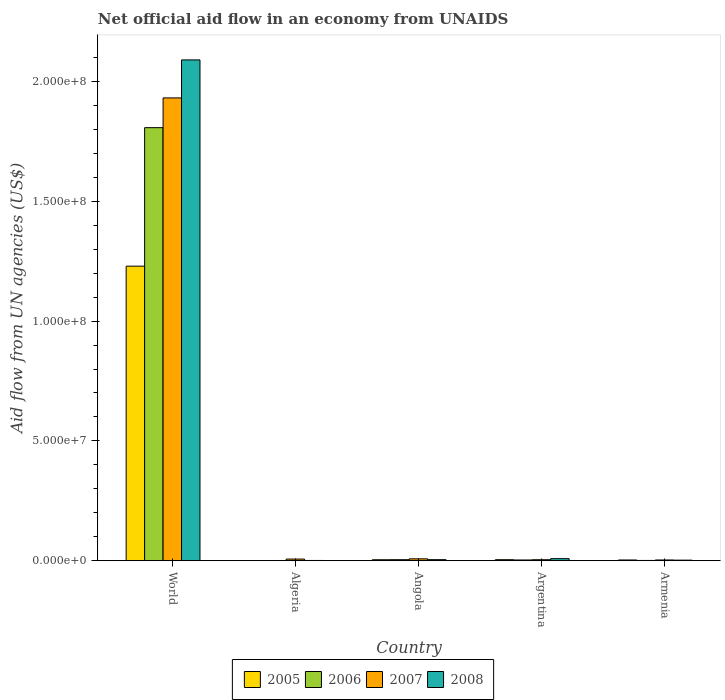Are the number of bars on each tick of the X-axis equal?
Provide a short and direct response. Yes. How many bars are there on the 3rd tick from the left?
Give a very brief answer. 4. How many bars are there on the 4th tick from the right?
Provide a succinct answer. 4. What is the label of the 4th group of bars from the left?
Give a very brief answer. Argentina. What is the net official aid flow in 2007 in World?
Provide a short and direct response. 1.93e+08. Across all countries, what is the maximum net official aid flow in 2005?
Your answer should be very brief. 1.23e+08. Across all countries, what is the minimum net official aid flow in 2007?
Offer a very short reply. 3.30e+05. In which country was the net official aid flow in 2007 minimum?
Offer a terse response. Armenia. What is the total net official aid flow in 2008 in the graph?
Your response must be concise. 2.11e+08. What is the difference between the net official aid flow in 2007 in Algeria and that in Angola?
Your response must be concise. -1.00e+05. What is the difference between the net official aid flow in 2006 in World and the net official aid flow in 2008 in Algeria?
Your response must be concise. 1.81e+08. What is the average net official aid flow in 2005 per country?
Make the answer very short. 2.48e+07. In how many countries, is the net official aid flow in 2007 greater than 50000000 US$?
Your answer should be very brief. 1. What is the ratio of the net official aid flow in 2005 in Algeria to that in Armenia?
Your response must be concise. 0.27. What is the difference between the highest and the second highest net official aid flow in 2006?
Your answer should be compact. 1.80e+08. What is the difference between the highest and the lowest net official aid flow in 2006?
Your answer should be very brief. 1.81e+08. Is it the case that in every country, the sum of the net official aid flow in 2008 and net official aid flow in 2006 is greater than the sum of net official aid flow in 2007 and net official aid flow in 2005?
Offer a very short reply. No. What does the 1st bar from the left in Armenia represents?
Offer a very short reply. 2005. How many bars are there?
Your answer should be very brief. 20. What is the difference between two consecutive major ticks on the Y-axis?
Provide a succinct answer. 5.00e+07. Are the values on the major ticks of Y-axis written in scientific E-notation?
Provide a succinct answer. Yes. Does the graph contain grids?
Your answer should be compact. No. Where does the legend appear in the graph?
Your answer should be very brief. Bottom center. How are the legend labels stacked?
Provide a short and direct response. Horizontal. What is the title of the graph?
Provide a short and direct response. Net official aid flow in an economy from UNAIDS. What is the label or title of the Y-axis?
Ensure brevity in your answer.  Aid flow from UN agencies (US$). What is the Aid flow from UN agencies (US$) of 2005 in World?
Provide a succinct answer. 1.23e+08. What is the Aid flow from UN agencies (US$) of 2006 in World?
Offer a very short reply. 1.81e+08. What is the Aid flow from UN agencies (US$) in 2007 in World?
Ensure brevity in your answer.  1.93e+08. What is the Aid flow from UN agencies (US$) of 2008 in World?
Provide a short and direct response. 2.09e+08. What is the Aid flow from UN agencies (US$) of 2006 in Algeria?
Provide a short and direct response. 9.00e+04. What is the Aid flow from UN agencies (US$) of 2007 in Algeria?
Provide a short and direct response. 7.10e+05. What is the Aid flow from UN agencies (US$) of 2005 in Angola?
Keep it short and to the point. 4.30e+05. What is the Aid flow from UN agencies (US$) in 2007 in Angola?
Make the answer very short. 8.10e+05. What is the Aid flow from UN agencies (US$) of 2008 in Angola?
Offer a very short reply. 4.60e+05. What is the Aid flow from UN agencies (US$) of 2007 in Argentina?
Offer a terse response. 4.40e+05. What is the Aid flow from UN agencies (US$) in 2008 in Argentina?
Provide a succinct answer. 8.90e+05. What is the Aid flow from UN agencies (US$) of 2005 in Armenia?
Ensure brevity in your answer.  3.30e+05. What is the Aid flow from UN agencies (US$) in 2008 in Armenia?
Provide a short and direct response. 2.60e+05. Across all countries, what is the maximum Aid flow from UN agencies (US$) of 2005?
Offer a terse response. 1.23e+08. Across all countries, what is the maximum Aid flow from UN agencies (US$) in 2006?
Ensure brevity in your answer.  1.81e+08. Across all countries, what is the maximum Aid flow from UN agencies (US$) in 2007?
Keep it short and to the point. 1.93e+08. Across all countries, what is the maximum Aid flow from UN agencies (US$) of 2008?
Offer a terse response. 2.09e+08. Across all countries, what is the minimum Aid flow from UN agencies (US$) of 2005?
Keep it short and to the point. 9.00e+04. Across all countries, what is the minimum Aid flow from UN agencies (US$) in 2006?
Provide a short and direct response. 9.00e+04. What is the total Aid flow from UN agencies (US$) of 2005 in the graph?
Your answer should be very brief. 1.24e+08. What is the total Aid flow from UN agencies (US$) of 2006 in the graph?
Keep it short and to the point. 1.82e+08. What is the total Aid flow from UN agencies (US$) in 2007 in the graph?
Your response must be concise. 1.95e+08. What is the total Aid flow from UN agencies (US$) of 2008 in the graph?
Your response must be concise. 2.11e+08. What is the difference between the Aid flow from UN agencies (US$) in 2005 in World and that in Algeria?
Your answer should be very brief. 1.23e+08. What is the difference between the Aid flow from UN agencies (US$) in 2006 in World and that in Algeria?
Make the answer very short. 1.81e+08. What is the difference between the Aid flow from UN agencies (US$) in 2007 in World and that in Algeria?
Offer a terse response. 1.92e+08. What is the difference between the Aid flow from UN agencies (US$) of 2008 in World and that in Algeria?
Your response must be concise. 2.09e+08. What is the difference between the Aid flow from UN agencies (US$) in 2005 in World and that in Angola?
Your answer should be compact. 1.22e+08. What is the difference between the Aid flow from UN agencies (US$) in 2006 in World and that in Angola?
Offer a terse response. 1.80e+08. What is the difference between the Aid flow from UN agencies (US$) of 2007 in World and that in Angola?
Provide a succinct answer. 1.92e+08. What is the difference between the Aid flow from UN agencies (US$) of 2008 in World and that in Angola?
Keep it short and to the point. 2.08e+08. What is the difference between the Aid flow from UN agencies (US$) in 2005 in World and that in Argentina?
Make the answer very short. 1.22e+08. What is the difference between the Aid flow from UN agencies (US$) of 2006 in World and that in Argentina?
Ensure brevity in your answer.  1.80e+08. What is the difference between the Aid flow from UN agencies (US$) in 2007 in World and that in Argentina?
Your answer should be compact. 1.93e+08. What is the difference between the Aid flow from UN agencies (US$) of 2008 in World and that in Argentina?
Keep it short and to the point. 2.08e+08. What is the difference between the Aid flow from UN agencies (US$) in 2005 in World and that in Armenia?
Provide a succinct answer. 1.23e+08. What is the difference between the Aid flow from UN agencies (US$) of 2006 in World and that in Armenia?
Keep it short and to the point. 1.81e+08. What is the difference between the Aid flow from UN agencies (US$) of 2007 in World and that in Armenia?
Make the answer very short. 1.93e+08. What is the difference between the Aid flow from UN agencies (US$) in 2008 in World and that in Armenia?
Give a very brief answer. 2.09e+08. What is the difference between the Aid flow from UN agencies (US$) of 2006 in Algeria and that in Angola?
Keep it short and to the point. -3.60e+05. What is the difference between the Aid flow from UN agencies (US$) of 2008 in Algeria and that in Angola?
Your response must be concise. -3.30e+05. What is the difference between the Aid flow from UN agencies (US$) of 2005 in Algeria and that in Argentina?
Your response must be concise. -3.60e+05. What is the difference between the Aid flow from UN agencies (US$) of 2007 in Algeria and that in Argentina?
Your answer should be very brief. 2.70e+05. What is the difference between the Aid flow from UN agencies (US$) in 2008 in Algeria and that in Argentina?
Provide a succinct answer. -7.60e+05. What is the difference between the Aid flow from UN agencies (US$) of 2006 in Algeria and that in Armenia?
Offer a very short reply. -5.00e+04. What is the difference between the Aid flow from UN agencies (US$) of 2008 in Algeria and that in Armenia?
Provide a short and direct response. -1.30e+05. What is the difference between the Aid flow from UN agencies (US$) of 2005 in Angola and that in Argentina?
Give a very brief answer. -2.00e+04. What is the difference between the Aid flow from UN agencies (US$) in 2006 in Angola and that in Argentina?
Provide a succinct answer. 1.20e+05. What is the difference between the Aid flow from UN agencies (US$) of 2008 in Angola and that in Argentina?
Your answer should be very brief. -4.30e+05. What is the difference between the Aid flow from UN agencies (US$) of 2005 in Angola and that in Armenia?
Provide a short and direct response. 1.00e+05. What is the difference between the Aid flow from UN agencies (US$) of 2006 in Angola and that in Armenia?
Offer a very short reply. 3.10e+05. What is the difference between the Aid flow from UN agencies (US$) in 2007 in Angola and that in Armenia?
Your response must be concise. 4.80e+05. What is the difference between the Aid flow from UN agencies (US$) of 2008 in Angola and that in Armenia?
Your answer should be very brief. 2.00e+05. What is the difference between the Aid flow from UN agencies (US$) of 2006 in Argentina and that in Armenia?
Your answer should be very brief. 1.90e+05. What is the difference between the Aid flow from UN agencies (US$) of 2008 in Argentina and that in Armenia?
Keep it short and to the point. 6.30e+05. What is the difference between the Aid flow from UN agencies (US$) in 2005 in World and the Aid flow from UN agencies (US$) in 2006 in Algeria?
Provide a succinct answer. 1.23e+08. What is the difference between the Aid flow from UN agencies (US$) of 2005 in World and the Aid flow from UN agencies (US$) of 2007 in Algeria?
Your answer should be very brief. 1.22e+08. What is the difference between the Aid flow from UN agencies (US$) in 2005 in World and the Aid flow from UN agencies (US$) in 2008 in Algeria?
Provide a short and direct response. 1.23e+08. What is the difference between the Aid flow from UN agencies (US$) in 2006 in World and the Aid flow from UN agencies (US$) in 2007 in Algeria?
Provide a succinct answer. 1.80e+08. What is the difference between the Aid flow from UN agencies (US$) of 2006 in World and the Aid flow from UN agencies (US$) of 2008 in Algeria?
Your answer should be compact. 1.81e+08. What is the difference between the Aid flow from UN agencies (US$) in 2007 in World and the Aid flow from UN agencies (US$) in 2008 in Algeria?
Ensure brevity in your answer.  1.93e+08. What is the difference between the Aid flow from UN agencies (US$) in 2005 in World and the Aid flow from UN agencies (US$) in 2006 in Angola?
Your response must be concise. 1.22e+08. What is the difference between the Aid flow from UN agencies (US$) in 2005 in World and the Aid flow from UN agencies (US$) in 2007 in Angola?
Provide a short and direct response. 1.22e+08. What is the difference between the Aid flow from UN agencies (US$) of 2005 in World and the Aid flow from UN agencies (US$) of 2008 in Angola?
Your answer should be compact. 1.22e+08. What is the difference between the Aid flow from UN agencies (US$) in 2006 in World and the Aid flow from UN agencies (US$) in 2007 in Angola?
Offer a terse response. 1.80e+08. What is the difference between the Aid flow from UN agencies (US$) of 2006 in World and the Aid flow from UN agencies (US$) of 2008 in Angola?
Keep it short and to the point. 1.80e+08. What is the difference between the Aid flow from UN agencies (US$) in 2007 in World and the Aid flow from UN agencies (US$) in 2008 in Angola?
Offer a terse response. 1.93e+08. What is the difference between the Aid flow from UN agencies (US$) of 2005 in World and the Aid flow from UN agencies (US$) of 2006 in Argentina?
Ensure brevity in your answer.  1.23e+08. What is the difference between the Aid flow from UN agencies (US$) of 2005 in World and the Aid flow from UN agencies (US$) of 2007 in Argentina?
Give a very brief answer. 1.22e+08. What is the difference between the Aid flow from UN agencies (US$) of 2005 in World and the Aid flow from UN agencies (US$) of 2008 in Argentina?
Provide a succinct answer. 1.22e+08. What is the difference between the Aid flow from UN agencies (US$) in 2006 in World and the Aid flow from UN agencies (US$) in 2007 in Argentina?
Provide a succinct answer. 1.80e+08. What is the difference between the Aid flow from UN agencies (US$) of 2006 in World and the Aid flow from UN agencies (US$) of 2008 in Argentina?
Offer a terse response. 1.80e+08. What is the difference between the Aid flow from UN agencies (US$) of 2007 in World and the Aid flow from UN agencies (US$) of 2008 in Argentina?
Offer a very short reply. 1.92e+08. What is the difference between the Aid flow from UN agencies (US$) in 2005 in World and the Aid flow from UN agencies (US$) in 2006 in Armenia?
Offer a very short reply. 1.23e+08. What is the difference between the Aid flow from UN agencies (US$) in 2005 in World and the Aid flow from UN agencies (US$) in 2007 in Armenia?
Make the answer very short. 1.23e+08. What is the difference between the Aid flow from UN agencies (US$) in 2005 in World and the Aid flow from UN agencies (US$) in 2008 in Armenia?
Offer a very short reply. 1.23e+08. What is the difference between the Aid flow from UN agencies (US$) in 2006 in World and the Aid flow from UN agencies (US$) in 2007 in Armenia?
Make the answer very short. 1.80e+08. What is the difference between the Aid flow from UN agencies (US$) of 2006 in World and the Aid flow from UN agencies (US$) of 2008 in Armenia?
Offer a terse response. 1.80e+08. What is the difference between the Aid flow from UN agencies (US$) of 2007 in World and the Aid flow from UN agencies (US$) of 2008 in Armenia?
Your response must be concise. 1.93e+08. What is the difference between the Aid flow from UN agencies (US$) of 2005 in Algeria and the Aid flow from UN agencies (US$) of 2006 in Angola?
Provide a succinct answer. -3.60e+05. What is the difference between the Aid flow from UN agencies (US$) of 2005 in Algeria and the Aid flow from UN agencies (US$) of 2007 in Angola?
Ensure brevity in your answer.  -7.20e+05. What is the difference between the Aid flow from UN agencies (US$) of 2005 in Algeria and the Aid flow from UN agencies (US$) of 2008 in Angola?
Offer a very short reply. -3.70e+05. What is the difference between the Aid flow from UN agencies (US$) in 2006 in Algeria and the Aid flow from UN agencies (US$) in 2007 in Angola?
Provide a succinct answer. -7.20e+05. What is the difference between the Aid flow from UN agencies (US$) of 2006 in Algeria and the Aid flow from UN agencies (US$) of 2008 in Angola?
Make the answer very short. -3.70e+05. What is the difference between the Aid flow from UN agencies (US$) of 2005 in Algeria and the Aid flow from UN agencies (US$) of 2007 in Argentina?
Provide a short and direct response. -3.50e+05. What is the difference between the Aid flow from UN agencies (US$) of 2005 in Algeria and the Aid flow from UN agencies (US$) of 2008 in Argentina?
Give a very brief answer. -8.00e+05. What is the difference between the Aid flow from UN agencies (US$) in 2006 in Algeria and the Aid flow from UN agencies (US$) in 2007 in Argentina?
Ensure brevity in your answer.  -3.50e+05. What is the difference between the Aid flow from UN agencies (US$) of 2006 in Algeria and the Aid flow from UN agencies (US$) of 2008 in Argentina?
Your answer should be compact. -8.00e+05. What is the difference between the Aid flow from UN agencies (US$) of 2007 in Algeria and the Aid flow from UN agencies (US$) of 2008 in Argentina?
Your answer should be very brief. -1.80e+05. What is the difference between the Aid flow from UN agencies (US$) of 2005 in Algeria and the Aid flow from UN agencies (US$) of 2006 in Armenia?
Keep it short and to the point. -5.00e+04. What is the difference between the Aid flow from UN agencies (US$) of 2006 in Algeria and the Aid flow from UN agencies (US$) of 2008 in Armenia?
Keep it short and to the point. -1.70e+05. What is the difference between the Aid flow from UN agencies (US$) of 2005 in Angola and the Aid flow from UN agencies (US$) of 2006 in Argentina?
Offer a very short reply. 1.00e+05. What is the difference between the Aid flow from UN agencies (US$) in 2005 in Angola and the Aid flow from UN agencies (US$) in 2007 in Argentina?
Provide a succinct answer. -10000. What is the difference between the Aid flow from UN agencies (US$) of 2005 in Angola and the Aid flow from UN agencies (US$) of 2008 in Argentina?
Provide a short and direct response. -4.60e+05. What is the difference between the Aid flow from UN agencies (US$) in 2006 in Angola and the Aid flow from UN agencies (US$) in 2007 in Argentina?
Your response must be concise. 10000. What is the difference between the Aid flow from UN agencies (US$) in 2006 in Angola and the Aid flow from UN agencies (US$) in 2008 in Argentina?
Offer a terse response. -4.40e+05. What is the difference between the Aid flow from UN agencies (US$) in 2005 in Angola and the Aid flow from UN agencies (US$) in 2007 in Armenia?
Offer a terse response. 1.00e+05. What is the difference between the Aid flow from UN agencies (US$) of 2006 in Angola and the Aid flow from UN agencies (US$) of 2008 in Armenia?
Ensure brevity in your answer.  1.90e+05. What is the difference between the Aid flow from UN agencies (US$) in 2005 in Argentina and the Aid flow from UN agencies (US$) in 2007 in Armenia?
Give a very brief answer. 1.20e+05. What is the difference between the Aid flow from UN agencies (US$) of 2005 in Argentina and the Aid flow from UN agencies (US$) of 2008 in Armenia?
Keep it short and to the point. 1.90e+05. What is the difference between the Aid flow from UN agencies (US$) in 2007 in Argentina and the Aid flow from UN agencies (US$) in 2008 in Armenia?
Provide a short and direct response. 1.80e+05. What is the average Aid flow from UN agencies (US$) of 2005 per country?
Your answer should be very brief. 2.48e+07. What is the average Aid flow from UN agencies (US$) of 2006 per country?
Give a very brief answer. 3.63e+07. What is the average Aid flow from UN agencies (US$) in 2007 per country?
Your answer should be very brief. 3.91e+07. What is the average Aid flow from UN agencies (US$) in 2008 per country?
Offer a terse response. 4.21e+07. What is the difference between the Aid flow from UN agencies (US$) in 2005 and Aid flow from UN agencies (US$) in 2006 in World?
Offer a terse response. -5.78e+07. What is the difference between the Aid flow from UN agencies (US$) of 2005 and Aid flow from UN agencies (US$) of 2007 in World?
Offer a terse response. -7.02e+07. What is the difference between the Aid flow from UN agencies (US$) of 2005 and Aid flow from UN agencies (US$) of 2008 in World?
Give a very brief answer. -8.60e+07. What is the difference between the Aid flow from UN agencies (US$) of 2006 and Aid flow from UN agencies (US$) of 2007 in World?
Your answer should be compact. -1.24e+07. What is the difference between the Aid flow from UN agencies (US$) in 2006 and Aid flow from UN agencies (US$) in 2008 in World?
Your answer should be compact. -2.83e+07. What is the difference between the Aid flow from UN agencies (US$) in 2007 and Aid flow from UN agencies (US$) in 2008 in World?
Offer a terse response. -1.58e+07. What is the difference between the Aid flow from UN agencies (US$) in 2005 and Aid flow from UN agencies (US$) in 2006 in Algeria?
Provide a short and direct response. 0. What is the difference between the Aid flow from UN agencies (US$) of 2005 and Aid flow from UN agencies (US$) of 2007 in Algeria?
Your answer should be very brief. -6.20e+05. What is the difference between the Aid flow from UN agencies (US$) in 2006 and Aid flow from UN agencies (US$) in 2007 in Algeria?
Ensure brevity in your answer.  -6.20e+05. What is the difference between the Aid flow from UN agencies (US$) in 2006 and Aid flow from UN agencies (US$) in 2008 in Algeria?
Provide a succinct answer. -4.00e+04. What is the difference between the Aid flow from UN agencies (US$) in 2007 and Aid flow from UN agencies (US$) in 2008 in Algeria?
Provide a short and direct response. 5.80e+05. What is the difference between the Aid flow from UN agencies (US$) of 2005 and Aid flow from UN agencies (US$) of 2006 in Angola?
Keep it short and to the point. -2.00e+04. What is the difference between the Aid flow from UN agencies (US$) in 2005 and Aid flow from UN agencies (US$) in 2007 in Angola?
Keep it short and to the point. -3.80e+05. What is the difference between the Aid flow from UN agencies (US$) of 2005 and Aid flow from UN agencies (US$) of 2008 in Angola?
Make the answer very short. -3.00e+04. What is the difference between the Aid flow from UN agencies (US$) of 2006 and Aid flow from UN agencies (US$) of 2007 in Angola?
Offer a very short reply. -3.60e+05. What is the difference between the Aid flow from UN agencies (US$) in 2007 and Aid flow from UN agencies (US$) in 2008 in Angola?
Provide a succinct answer. 3.50e+05. What is the difference between the Aid flow from UN agencies (US$) of 2005 and Aid flow from UN agencies (US$) of 2007 in Argentina?
Your answer should be compact. 10000. What is the difference between the Aid flow from UN agencies (US$) of 2005 and Aid flow from UN agencies (US$) of 2008 in Argentina?
Ensure brevity in your answer.  -4.40e+05. What is the difference between the Aid flow from UN agencies (US$) in 2006 and Aid flow from UN agencies (US$) in 2007 in Argentina?
Keep it short and to the point. -1.10e+05. What is the difference between the Aid flow from UN agencies (US$) of 2006 and Aid flow from UN agencies (US$) of 2008 in Argentina?
Provide a short and direct response. -5.60e+05. What is the difference between the Aid flow from UN agencies (US$) of 2007 and Aid flow from UN agencies (US$) of 2008 in Argentina?
Your answer should be very brief. -4.50e+05. What is the difference between the Aid flow from UN agencies (US$) of 2005 and Aid flow from UN agencies (US$) of 2006 in Armenia?
Your response must be concise. 1.90e+05. What is the difference between the Aid flow from UN agencies (US$) in 2005 and Aid flow from UN agencies (US$) in 2007 in Armenia?
Your response must be concise. 0. What is the difference between the Aid flow from UN agencies (US$) in 2006 and Aid flow from UN agencies (US$) in 2007 in Armenia?
Your response must be concise. -1.90e+05. What is the difference between the Aid flow from UN agencies (US$) of 2006 and Aid flow from UN agencies (US$) of 2008 in Armenia?
Keep it short and to the point. -1.20e+05. What is the ratio of the Aid flow from UN agencies (US$) of 2005 in World to that in Algeria?
Keep it short and to the point. 1365.67. What is the ratio of the Aid flow from UN agencies (US$) in 2006 in World to that in Algeria?
Give a very brief answer. 2007.67. What is the ratio of the Aid flow from UN agencies (US$) in 2007 in World to that in Algeria?
Give a very brief answer. 271.97. What is the ratio of the Aid flow from UN agencies (US$) in 2008 in World to that in Algeria?
Provide a short and direct response. 1607.31. What is the ratio of the Aid flow from UN agencies (US$) of 2005 in World to that in Angola?
Your answer should be compact. 285.84. What is the ratio of the Aid flow from UN agencies (US$) in 2006 in World to that in Angola?
Your answer should be compact. 401.53. What is the ratio of the Aid flow from UN agencies (US$) of 2007 in World to that in Angola?
Keep it short and to the point. 238.4. What is the ratio of the Aid flow from UN agencies (US$) of 2008 in World to that in Angola?
Offer a very short reply. 454.24. What is the ratio of the Aid flow from UN agencies (US$) in 2005 in World to that in Argentina?
Offer a terse response. 273.13. What is the ratio of the Aid flow from UN agencies (US$) in 2006 in World to that in Argentina?
Keep it short and to the point. 547.55. What is the ratio of the Aid flow from UN agencies (US$) of 2007 in World to that in Argentina?
Offer a very short reply. 438.86. What is the ratio of the Aid flow from UN agencies (US$) of 2008 in World to that in Argentina?
Your answer should be very brief. 234.78. What is the ratio of the Aid flow from UN agencies (US$) in 2005 in World to that in Armenia?
Give a very brief answer. 372.45. What is the ratio of the Aid flow from UN agencies (US$) in 2006 in World to that in Armenia?
Give a very brief answer. 1290.64. What is the ratio of the Aid flow from UN agencies (US$) of 2007 in World to that in Armenia?
Make the answer very short. 585.15. What is the ratio of the Aid flow from UN agencies (US$) in 2008 in World to that in Armenia?
Ensure brevity in your answer.  803.65. What is the ratio of the Aid flow from UN agencies (US$) in 2005 in Algeria to that in Angola?
Ensure brevity in your answer.  0.21. What is the ratio of the Aid flow from UN agencies (US$) of 2007 in Algeria to that in Angola?
Your response must be concise. 0.88. What is the ratio of the Aid flow from UN agencies (US$) of 2008 in Algeria to that in Angola?
Make the answer very short. 0.28. What is the ratio of the Aid flow from UN agencies (US$) of 2005 in Algeria to that in Argentina?
Your response must be concise. 0.2. What is the ratio of the Aid flow from UN agencies (US$) of 2006 in Algeria to that in Argentina?
Give a very brief answer. 0.27. What is the ratio of the Aid flow from UN agencies (US$) in 2007 in Algeria to that in Argentina?
Your answer should be compact. 1.61. What is the ratio of the Aid flow from UN agencies (US$) of 2008 in Algeria to that in Argentina?
Your response must be concise. 0.15. What is the ratio of the Aid flow from UN agencies (US$) in 2005 in Algeria to that in Armenia?
Make the answer very short. 0.27. What is the ratio of the Aid flow from UN agencies (US$) in 2006 in Algeria to that in Armenia?
Your answer should be compact. 0.64. What is the ratio of the Aid flow from UN agencies (US$) of 2007 in Algeria to that in Armenia?
Your answer should be compact. 2.15. What is the ratio of the Aid flow from UN agencies (US$) in 2005 in Angola to that in Argentina?
Your answer should be very brief. 0.96. What is the ratio of the Aid flow from UN agencies (US$) of 2006 in Angola to that in Argentina?
Keep it short and to the point. 1.36. What is the ratio of the Aid flow from UN agencies (US$) of 2007 in Angola to that in Argentina?
Provide a short and direct response. 1.84. What is the ratio of the Aid flow from UN agencies (US$) of 2008 in Angola to that in Argentina?
Ensure brevity in your answer.  0.52. What is the ratio of the Aid flow from UN agencies (US$) in 2005 in Angola to that in Armenia?
Keep it short and to the point. 1.3. What is the ratio of the Aid flow from UN agencies (US$) of 2006 in Angola to that in Armenia?
Provide a short and direct response. 3.21. What is the ratio of the Aid flow from UN agencies (US$) of 2007 in Angola to that in Armenia?
Keep it short and to the point. 2.45. What is the ratio of the Aid flow from UN agencies (US$) of 2008 in Angola to that in Armenia?
Make the answer very short. 1.77. What is the ratio of the Aid flow from UN agencies (US$) of 2005 in Argentina to that in Armenia?
Ensure brevity in your answer.  1.36. What is the ratio of the Aid flow from UN agencies (US$) of 2006 in Argentina to that in Armenia?
Provide a succinct answer. 2.36. What is the ratio of the Aid flow from UN agencies (US$) of 2008 in Argentina to that in Armenia?
Your response must be concise. 3.42. What is the difference between the highest and the second highest Aid flow from UN agencies (US$) in 2005?
Offer a very short reply. 1.22e+08. What is the difference between the highest and the second highest Aid flow from UN agencies (US$) of 2006?
Ensure brevity in your answer.  1.80e+08. What is the difference between the highest and the second highest Aid flow from UN agencies (US$) in 2007?
Ensure brevity in your answer.  1.92e+08. What is the difference between the highest and the second highest Aid flow from UN agencies (US$) in 2008?
Give a very brief answer. 2.08e+08. What is the difference between the highest and the lowest Aid flow from UN agencies (US$) in 2005?
Your response must be concise. 1.23e+08. What is the difference between the highest and the lowest Aid flow from UN agencies (US$) in 2006?
Offer a very short reply. 1.81e+08. What is the difference between the highest and the lowest Aid flow from UN agencies (US$) of 2007?
Provide a short and direct response. 1.93e+08. What is the difference between the highest and the lowest Aid flow from UN agencies (US$) of 2008?
Your answer should be very brief. 2.09e+08. 